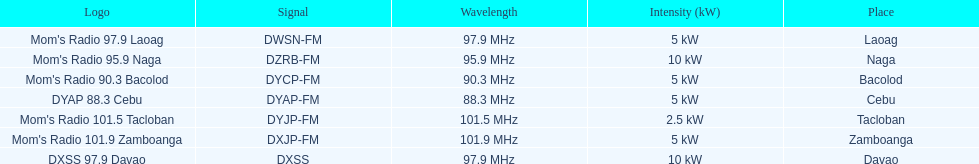What is the number of these stations broadcasting at a frequency of greater than 100 mhz? 2. 